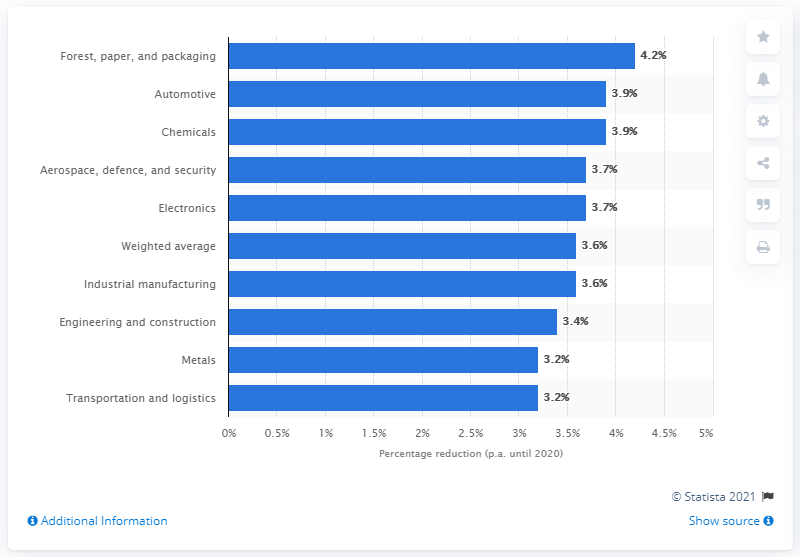Draw attention to some important aspects in this diagram. The projected reduction in costs per annum for the forest, paper, and packaging industry is 4.2%. 